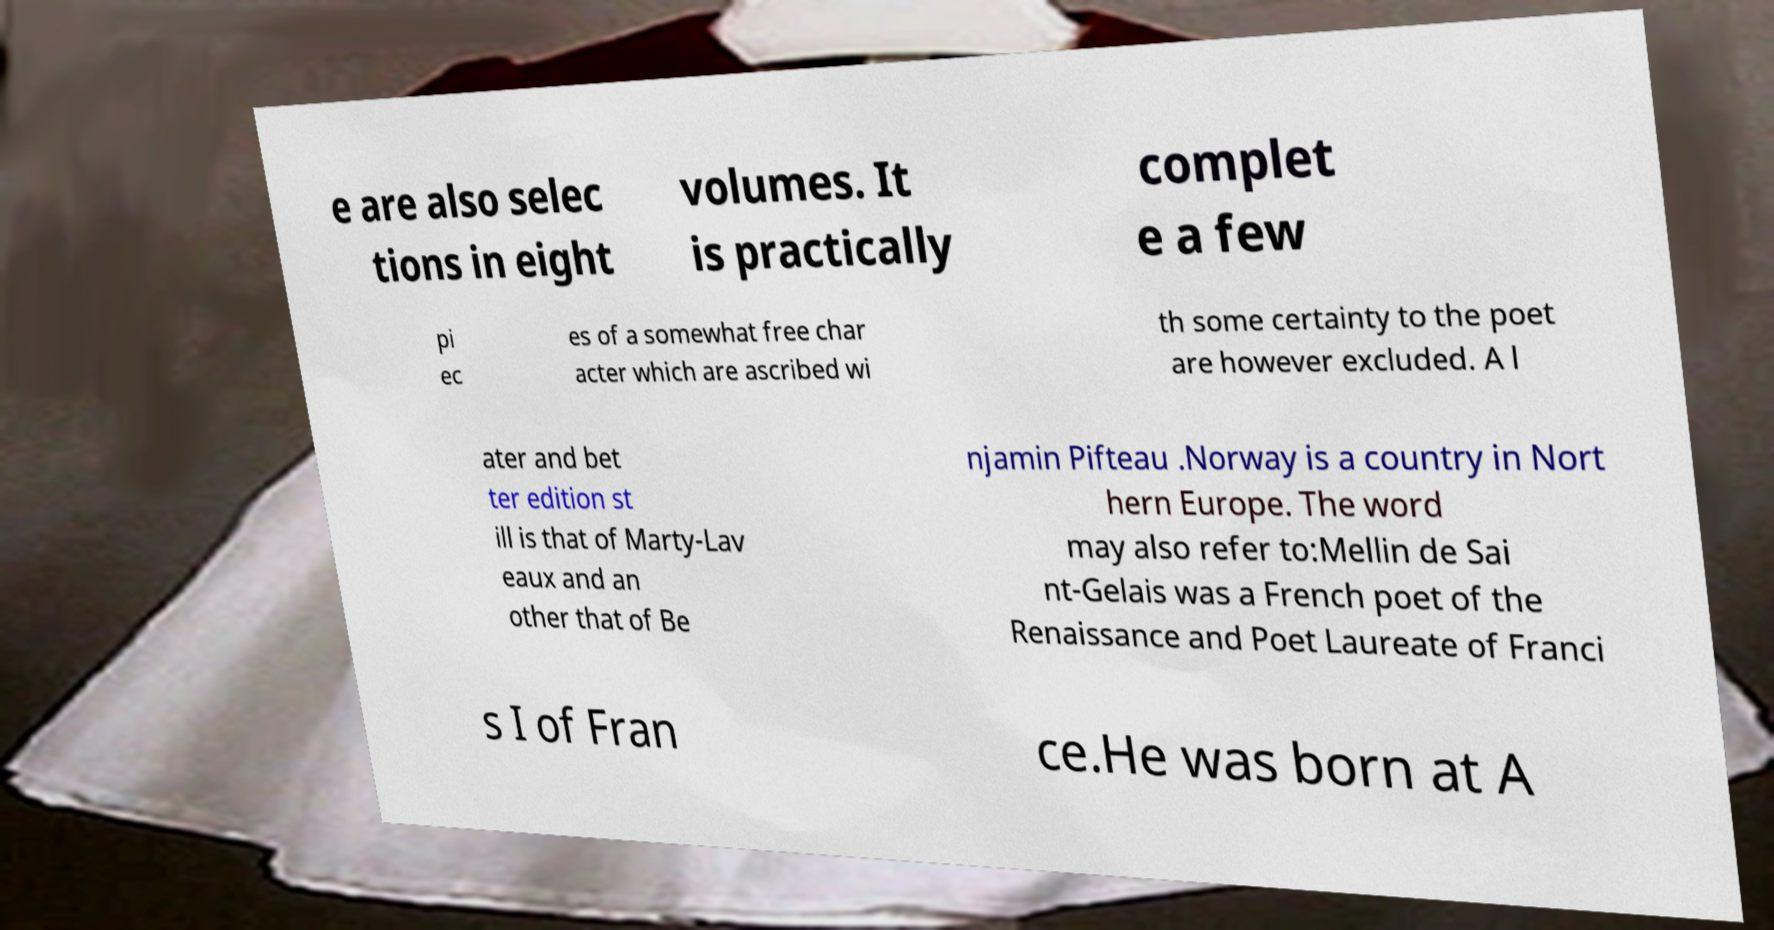Can you accurately transcribe the text from the provided image for me? e are also selec tions in eight volumes. It is practically complet e a few pi ec es of a somewhat free char acter which are ascribed wi th some certainty to the poet are however excluded. A l ater and bet ter edition st ill is that of Marty-Lav eaux and an other that of Be njamin Pifteau .Norway is a country in Nort hern Europe. The word may also refer to:Mellin de Sai nt-Gelais was a French poet of the Renaissance and Poet Laureate of Franci s I of Fran ce.He was born at A 